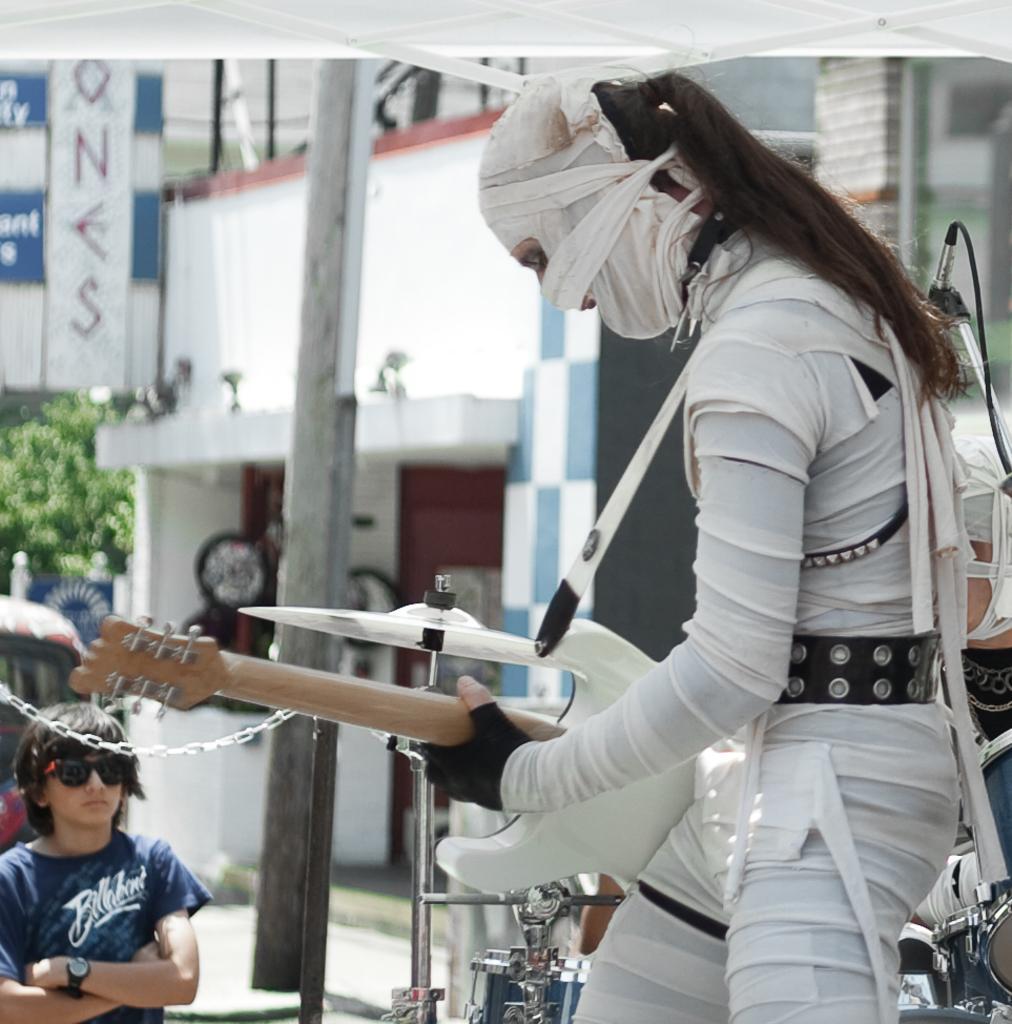Could you give a brief overview of what you see in this image? In this image we can see a man is standing and holding guitar in his hand. He is wearing white color dress. Bottom left of the image one boy is standing who is wearing dark blue color t-shirt. Back ground of the image tree, pole and buildings are present. Right bottom of the image drum is there. 